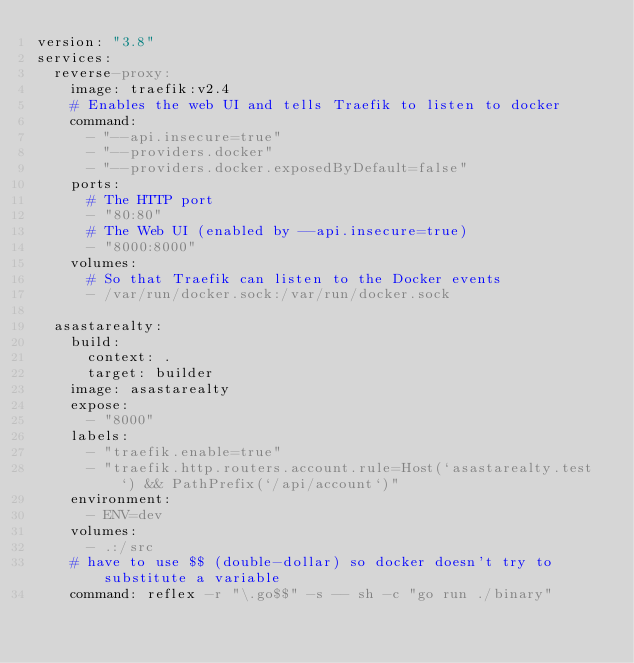Convert code to text. <code><loc_0><loc_0><loc_500><loc_500><_YAML_>version: "3.8"
services:
  reverse-proxy:
    image: traefik:v2.4
    # Enables the web UI and tells Traefik to listen to docker
    command:
      - "--api.insecure=true"
      - "--providers.docker"
      - "--providers.docker.exposedByDefault=false"
    ports:
      # The HTTP port
      - "80:80"
      # The Web UI (enabled by --api.insecure=true)
      - "8000:8000"
    volumes:
      # So that Traefik can listen to the Docker events
      - /var/run/docker.sock:/var/run/docker.sock

  asastarealty:
    build:
      context: .
      target: builder
    image: asastarealty
    expose:
      - "8000"
    labels:
      - "traefik.enable=true"
      - "traefik.http.routers.account.rule=Host(`asastarealty.test`) && PathPrefix(`/api/account`)"
    environment:
      - ENV=dev
    volumes:
      - .:/src
    # have to use $$ (double-dollar) so docker doesn't try to substitute a variable
    command: reflex -r "\.go$$" -s -- sh -c "go run ./binary"</code> 